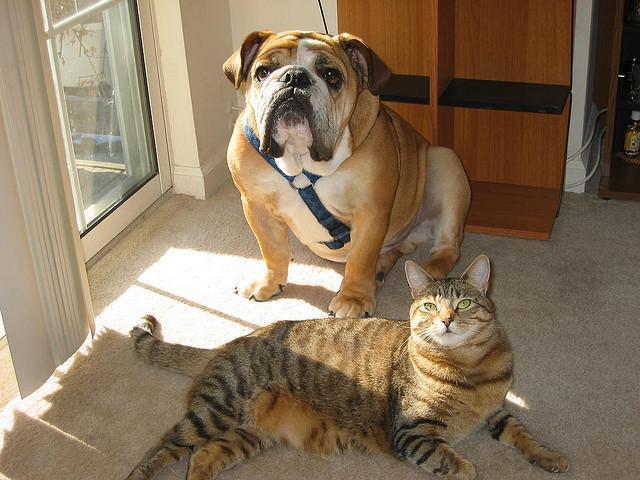How many pets do you see?
Give a very brief answer. 2. How many of the cows are calves?
Give a very brief answer. 0. 